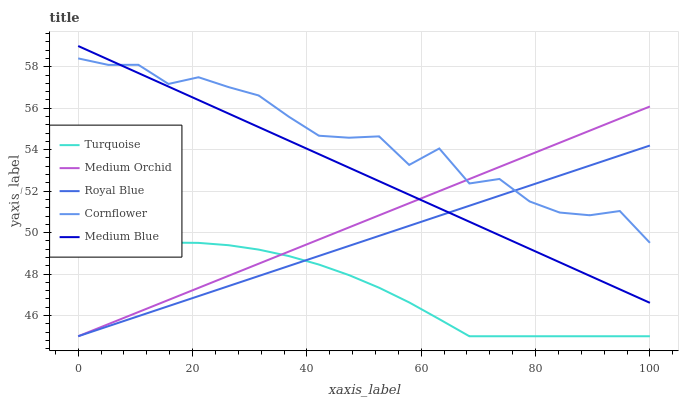Does Turquoise have the minimum area under the curve?
Answer yes or no. Yes. Does Cornflower have the maximum area under the curve?
Answer yes or no. Yes. Does Medium Orchid have the minimum area under the curve?
Answer yes or no. No. Does Medium Orchid have the maximum area under the curve?
Answer yes or no. No. Is Royal Blue the smoothest?
Answer yes or no. Yes. Is Cornflower the roughest?
Answer yes or no. Yes. Is Turquoise the smoothest?
Answer yes or no. No. Is Turquoise the roughest?
Answer yes or no. No. Does Royal Blue have the lowest value?
Answer yes or no. Yes. Does Medium Blue have the lowest value?
Answer yes or no. No. Does Medium Blue have the highest value?
Answer yes or no. Yes. Does Medium Orchid have the highest value?
Answer yes or no. No. Is Turquoise less than Medium Blue?
Answer yes or no. Yes. Is Cornflower greater than Turquoise?
Answer yes or no. Yes. Does Medium Orchid intersect Royal Blue?
Answer yes or no. Yes. Is Medium Orchid less than Royal Blue?
Answer yes or no. No. Is Medium Orchid greater than Royal Blue?
Answer yes or no. No. Does Turquoise intersect Medium Blue?
Answer yes or no. No. 